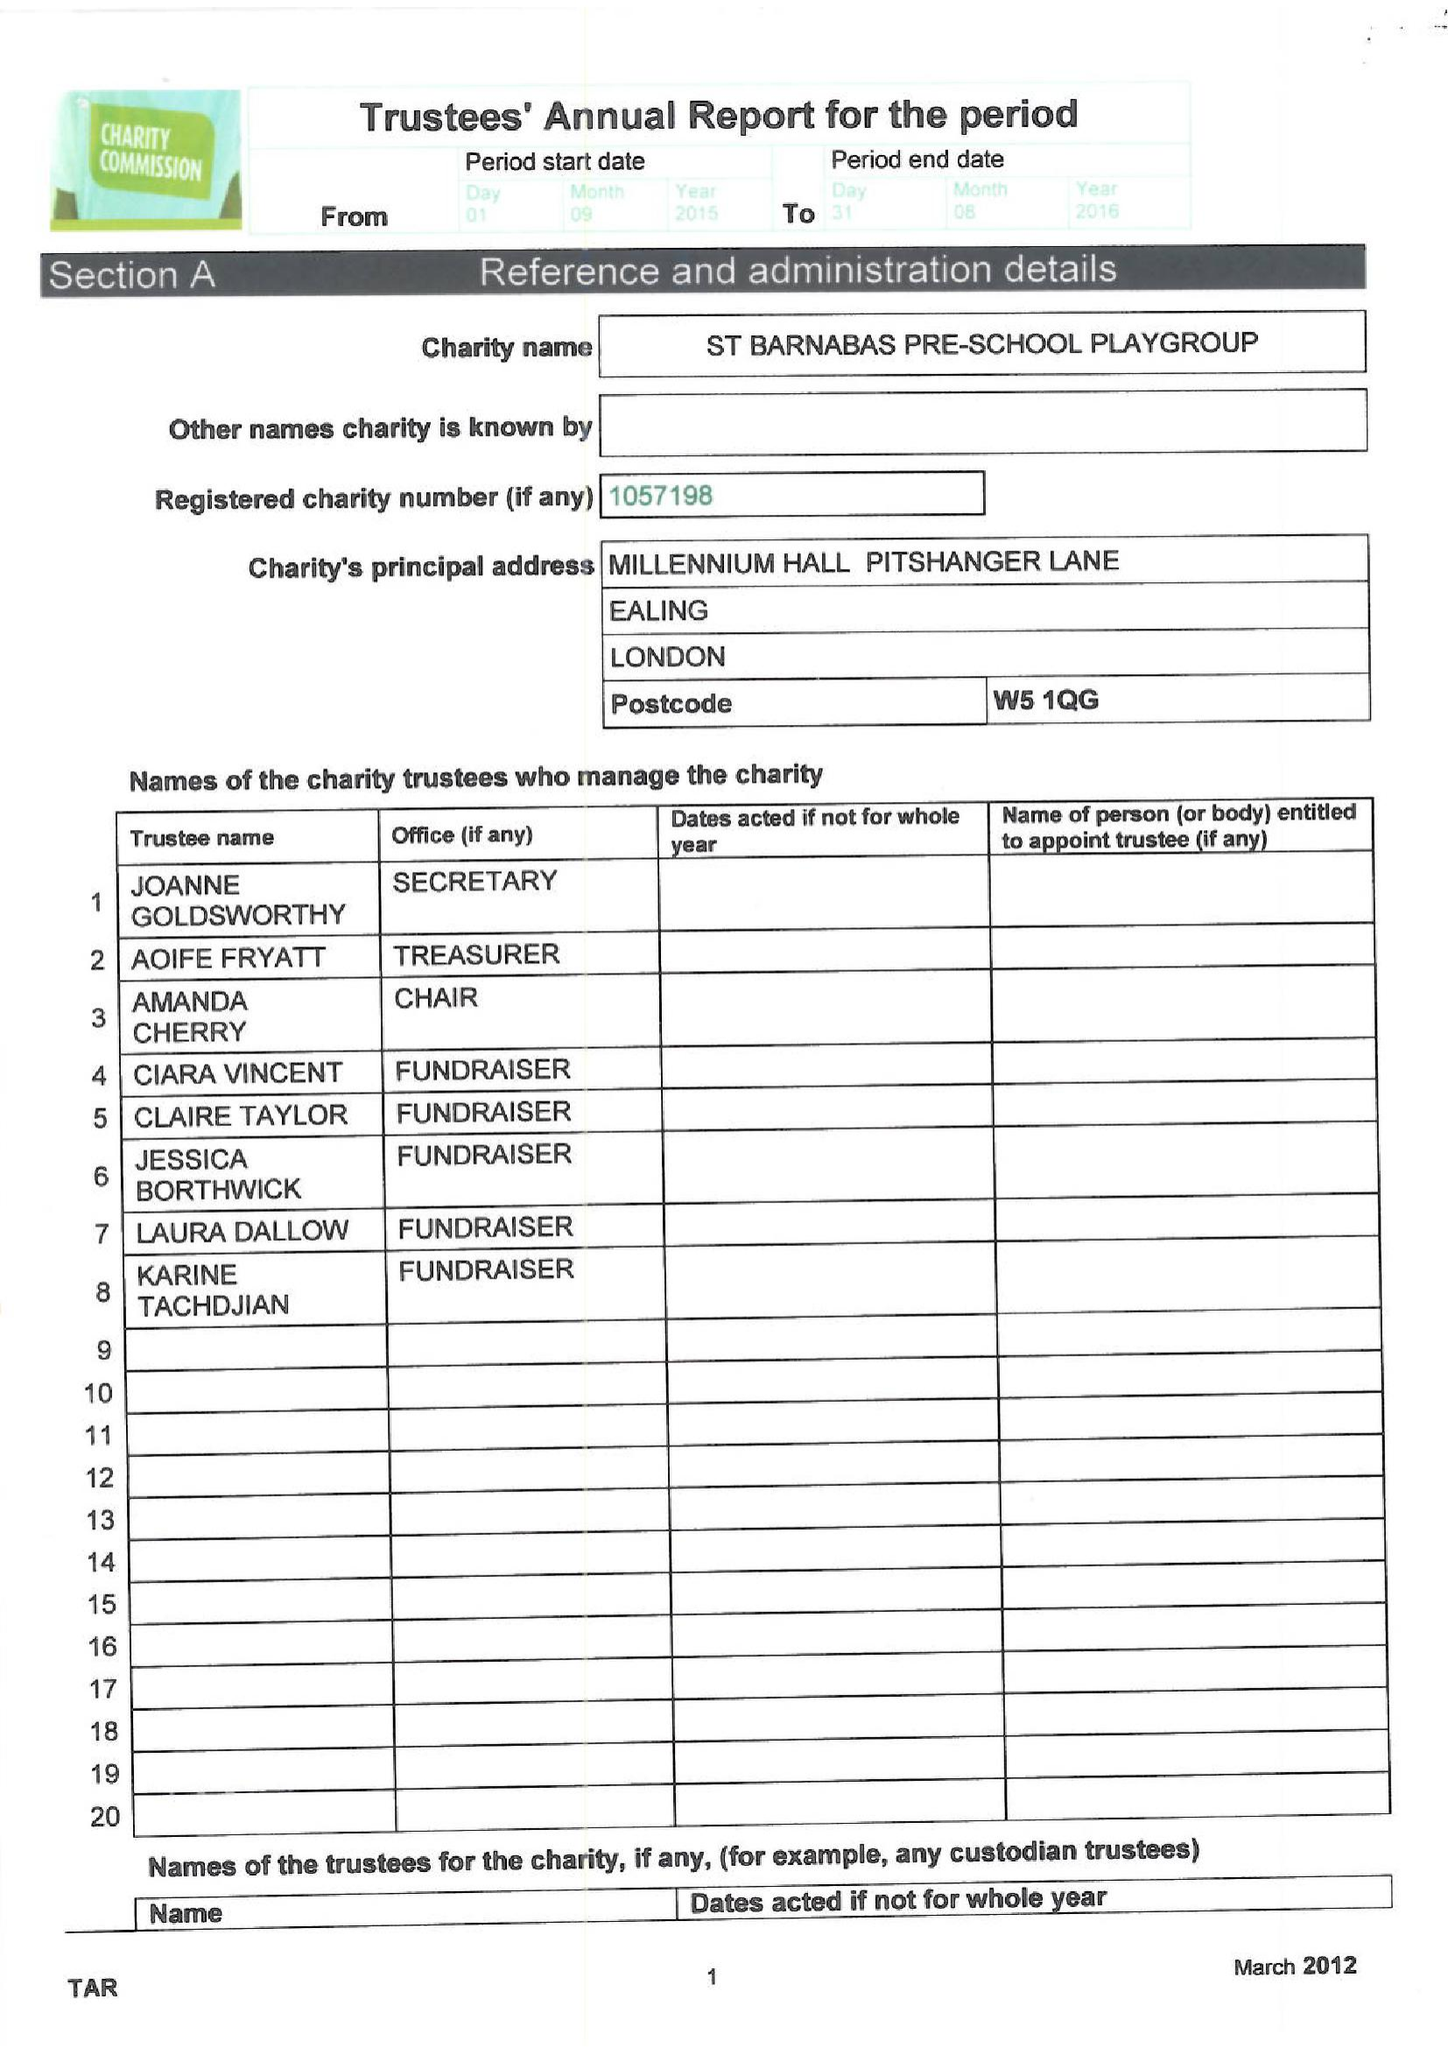What is the value for the address__street_line?
Answer the question using a single word or phrase. PITSHANGER LANE 